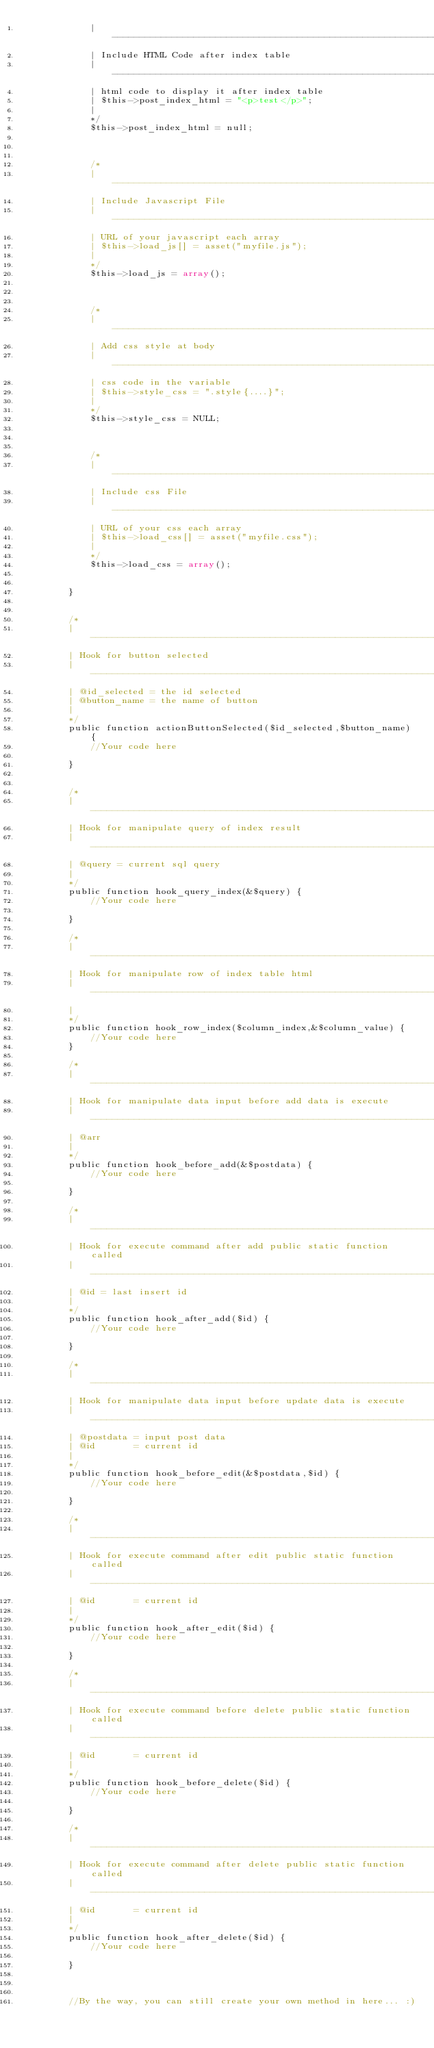<code> <loc_0><loc_0><loc_500><loc_500><_PHP_>	        | ---------------------------------------------------------------------- 
	        | Include HTML Code after index table 
	        | ---------------------------------------------------------------------- 
	        | html code to display it after index table
	        | $this->post_index_html = "<p>test</p>";
	        |
	        */
	        $this->post_index_html = null;
	        
	        
	        
	        /*
	        | ---------------------------------------------------------------------- 
	        | Include Javascript File 
	        | ---------------------------------------------------------------------- 
	        | URL of your javascript each array 
	        | $this->load_js[] = asset("myfile.js");
	        |
	        */
	        $this->load_js = array();
	        
	        
	        
	        /*
	        | ---------------------------------------------------------------------- 
	        | Add css style at body 
	        | ---------------------------------------------------------------------- 
	        | css code in the variable 
	        | $this->style_css = ".style{....}";
	        |
	        */
	        $this->style_css = NULL;
	        
	        
	        
	        /*
	        | ---------------------------------------------------------------------- 
	        | Include css File 
	        | ---------------------------------------------------------------------- 
	        | URL of your css each array 
	        | $this->load_css[] = asset("myfile.css");
	        |
	        */
	        $this->load_css = array();
	        
	        
	    }


	    /*
	    | ---------------------------------------------------------------------- 
	    | Hook for button selected
	    | ---------------------------------------------------------------------- 
	    | @id_selected = the id selected
	    | @button_name = the name of button
	    |
	    */
	    public function actionButtonSelected($id_selected,$button_name) {
	        //Your code here
	            
	    }


	    /*
	    | ---------------------------------------------------------------------- 
	    | Hook for manipulate query of index result 
	    | ---------------------------------------------------------------------- 
	    | @query = current sql query 
	    |
	    */
	    public function hook_query_index(&$query) {
	        //Your code here
	            
	    }

	    /*
	    | ---------------------------------------------------------------------- 
	    | Hook for manipulate row of index table html 
	    | ---------------------------------------------------------------------- 
	    |
	    */    
	    public function hook_row_index($column_index,&$column_value) {	        
	    	//Your code here
	    }

	    /*
	    | ---------------------------------------------------------------------- 
	    | Hook for manipulate data input before add data is execute
	    | ---------------------------------------------------------------------- 
	    | @arr
	    |
	    */
	    public function hook_before_add(&$postdata) {        
	        //Your code here

	    }

	    /* 
	    | ---------------------------------------------------------------------- 
	    | Hook for execute command after add public static function called 
	    | ---------------------------------------------------------------------- 
	    | @id = last insert id
	    | 
	    */
	    public function hook_after_add($id) {        
	        //Your code here

	    }

	    /* 
	    | ---------------------------------------------------------------------- 
	    | Hook for manipulate data input before update data is execute
	    | ---------------------------------------------------------------------- 
	    | @postdata = input post data 
	    | @id       = current id 
	    | 
	    */
	    public function hook_before_edit(&$postdata,$id) {        
	        //Your code here

	    }

	    /* 
	    | ---------------------------------------------------------------------- 
	    | Hook for execute command after edit public static function called
	    | ----------------------------------------------------------------------     
	    | @id       = current id 
	    | 
	    */
	    public function hook_after_edit($id) {
	        //Your code here 

	    }

	    /* 
	    | ---------------------------------------------------------------------- 
	    | Hook for execute command before delete public static function called
	    | ----------------------------------------------------------------------     
	    | @id       = current id 
	    | 
	    */
	    public function hook_before_delete($id) {
	        //Your code here

	    }

	    /* 
	    | ---------------------------------------------------------------------- 
	    | Hook for execute command after delete public static function called
	    | ----------------------------------------------------------------------     
	    | @id       = current id 
	    | 
	    */
	    public function hook_after_delete($id) {
	        //Your code here

	    }



	    //By the way, you can still create your own method in here... :) 

</code> 